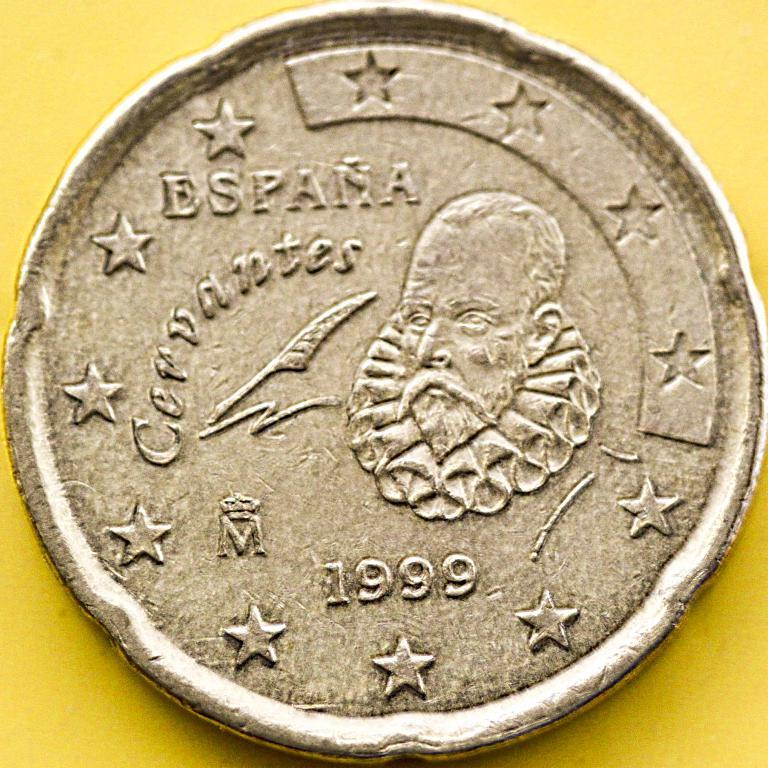Provide a one-sentence caption for the provided image. A rare coin from Spain it reads Espana Corvantes. 